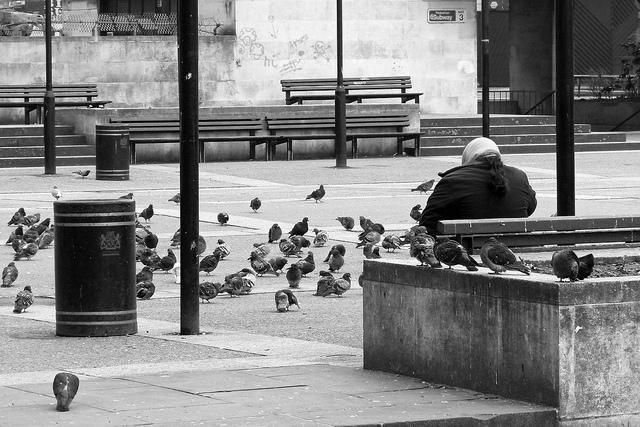Why are all the pigeons around the woman?
Answer the question by selecting the correct answer among the 4 following choices.
Options: Like her, coincidence, feeding them, trained pigeons. Feeding them. 